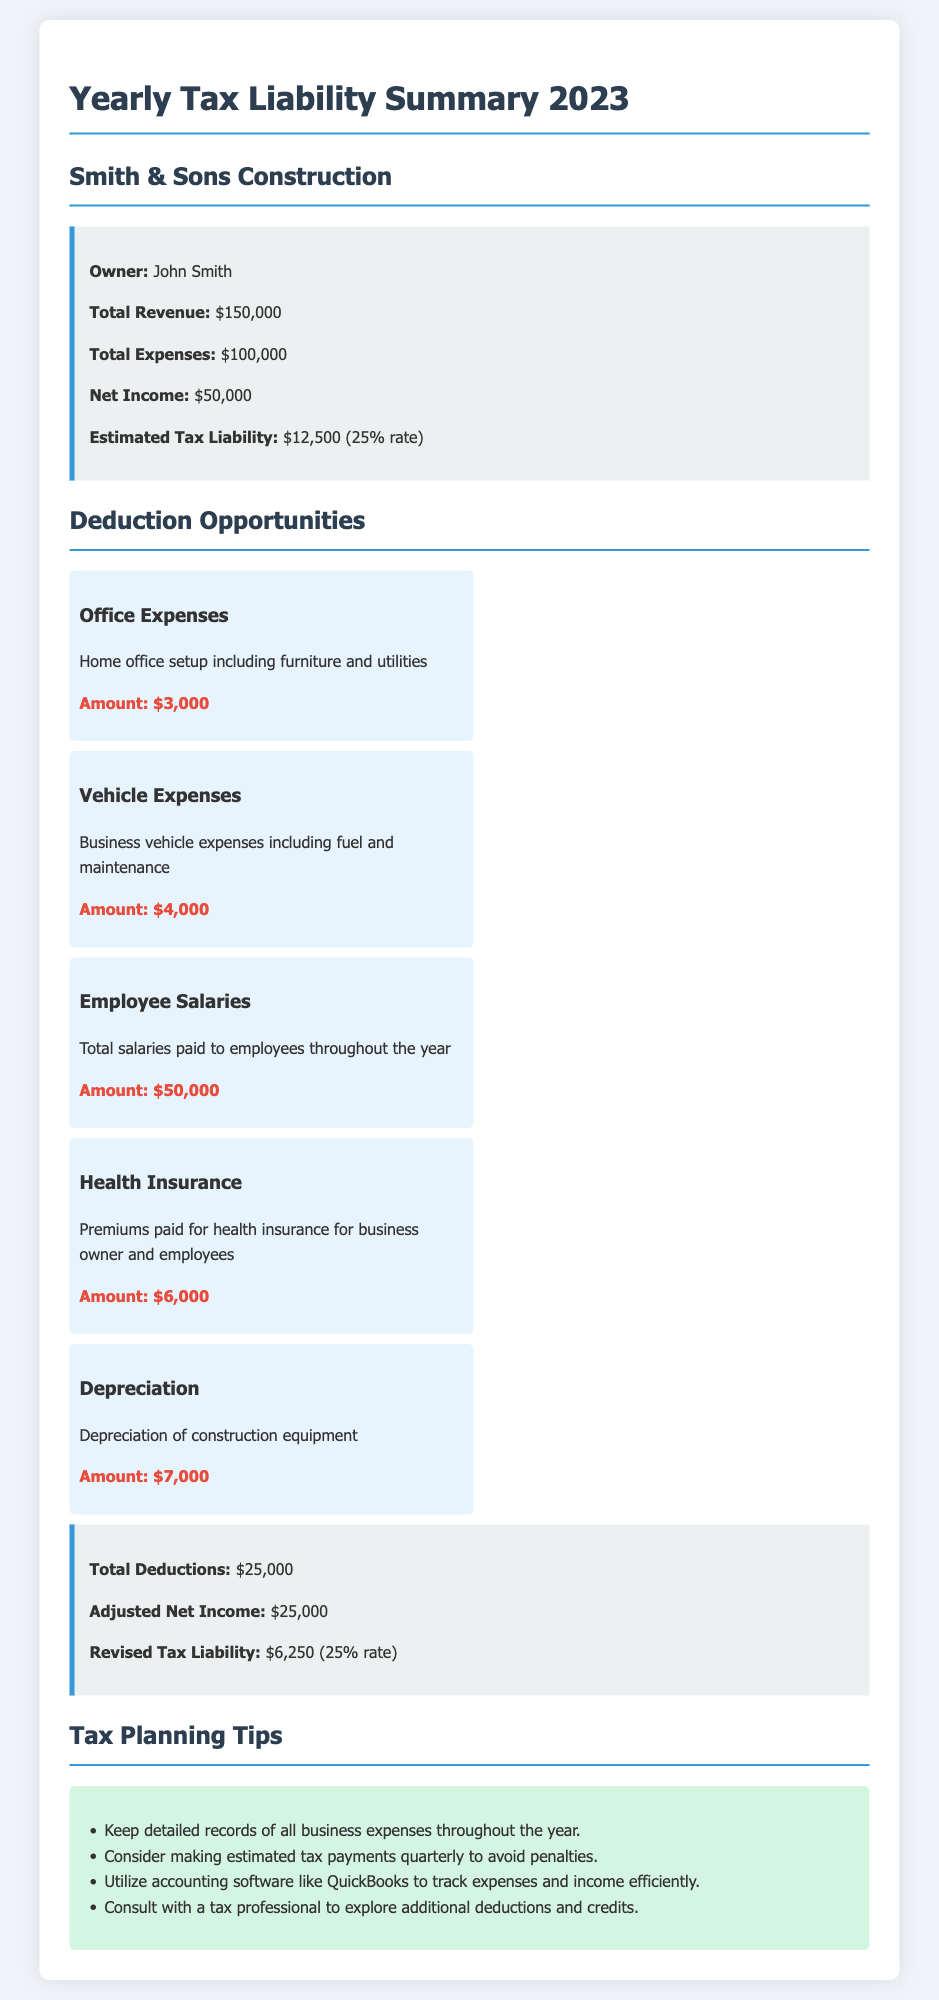What is the owner's name? The owner's name is mentioned at the top of the summary as John Smith.
Answer: John Smith What is the total expenses? The total expenses are clearly stated in the summary section of the document as $100,000.
Answer: $100,000 What is the estimated tax liability? The estimated tax liability is provided in the summary and is calculated based on the net income at a 25% tax rate as $12,500.
Answer: $12,500 What is the amount for employee salaries deduction? The deduction for employee salaries is listed among the deduction opportunities in the document as $50,000.
Answer: $50,000 How much are total deductions? Total deductions are summarized at the bottom of the deductions section and are $25,000.
Answer: $25,000 What is the revised tax liability? The revised tax liability is calculated after deductions and is mentioned in the summary section as $6,250.
Answer: $6,250 What is the amount for vehicle expenses deduction? The amount specified for vehicle expenses in the deductions section is $4,000.
Answer: $4,000 How is the adjusted net income calculated? The adjusted net income is derived by subtracting total deductions from net income, which is $50,000 - $25,000 = $25,000.
Answer: $25,000 What tax planning tip suggests consulting a tax professional? The tax planning tips section encourages consulting with a tax professional to explore additional deductions and credits.
Answer: Consult with a tax professional 